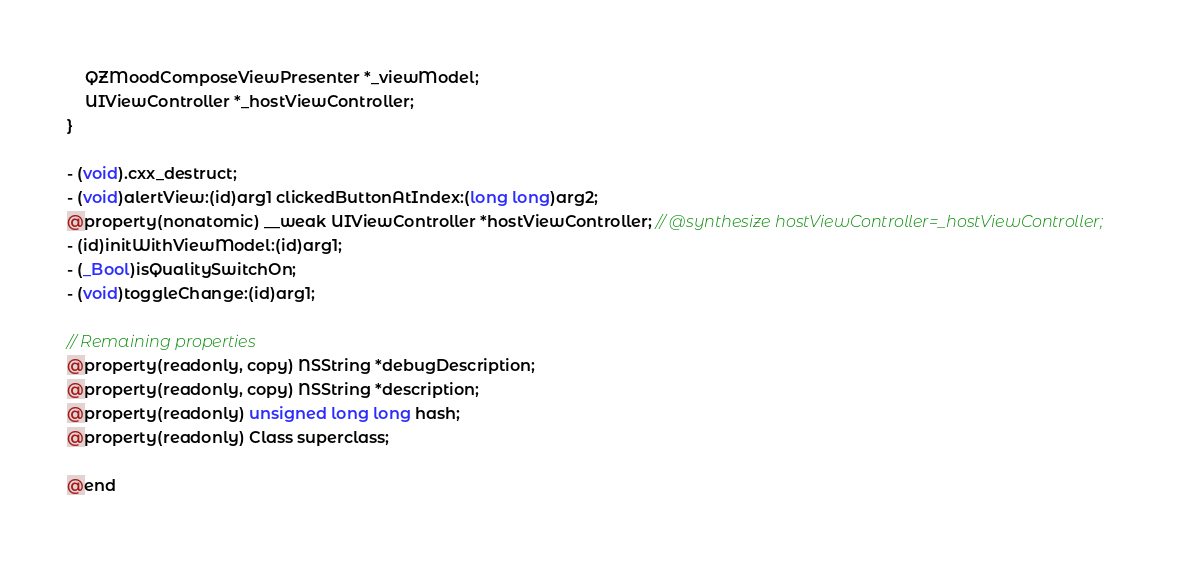<code> <loc_0><loc_0><loc_500><loc_500><_C_>    QZMoodComposeViewPresenter *_viewModel;
    UIViewController *_hostViewController;
}

- (void).cxx_destruct;
- (void)alertView:(id)arg1 clickedButtonAtIndex:(long long)arg2;
@property(nonatomic) __weak UIViewController *hostViewController; // @synthesize hostViewController=_hostViewController;
- (id)initWithViewModel:(id)arg1;
- (_Bool)isQualitySwitchOn;
- (void)toggleChange:(id)arg1;

// Remaining properties
@property(readonly, copy) NSString *debugDescription;
@property(readonly, copy) NSString *description;
@property(readonly) unsigned long long hash;
@property(readonly) Class superclass;

@end

</code> 